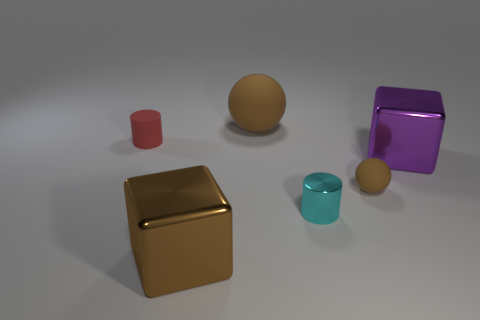Does the tiny object that is to the left of the large matte object have the same material as the large ball?
Make the answer very short. Yes. Is the number of cyan objects that are behind the big ball the same as the number of cubes in front of the big purple thing?
Ensure brevity in your answer.  No. How big is the cylinder that is right of the tiny red object?
Keep it short and to the point. Small. Is there a large brown sphere that has the same material as the small red thing?
Provide a short and direct response. Yes. Do the large thing that is in front of the small rubber sphere and the tiny ball have the same color?
Your answer should be very brief. Yes. Are there an equal number of cylinders behind the large brown matte object and green metallic spheres?
Make the answer very short. Yes. Is there a large metallic thing of the same color as the tiny sphere?
Make the answer very short. Yes. Is the size of the purple object the same as the cyan metal cylinder?
Give a very brief answer. No. How big is the cylinder that is left of the brown object on the left side of the big brown ball?
Provide a short and direct response. Small. There is a brown object that is in front of the rubber cylinder and behind the big brown metallic thing; how big is it?
Provide a short and direct response. Small. 